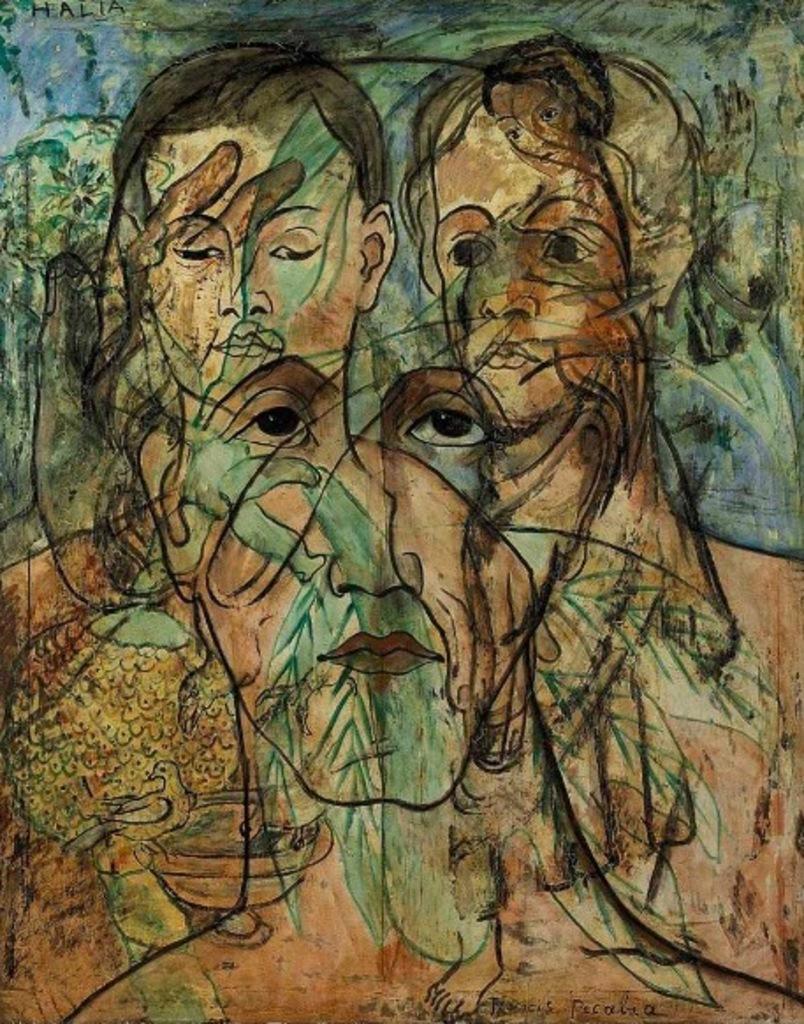Describe this image in one or two sentences. This image is a painting and in this image we can see human faces. 